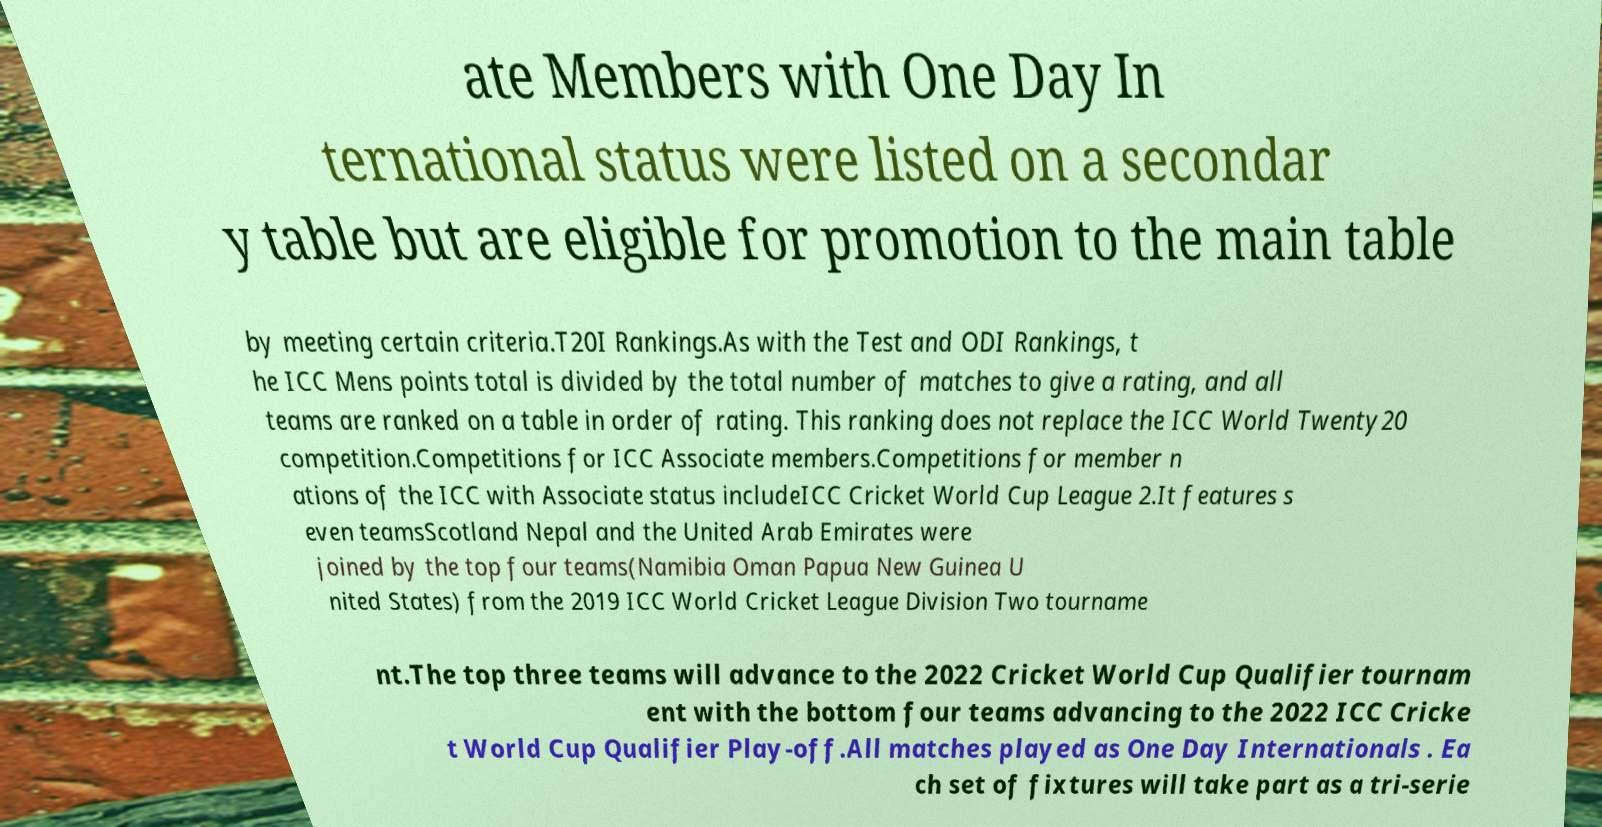For documentation purposes, I need the text within this image transcribed. Could you provide that? ate Members with One Day In ternational status were listed on a secondar y table but are eligible for promotion to the main table by meeting certain criteria.T20I Rankings.As with the Test and ODI Rankings, t he ICC Mens points total is divided by the total number of matches to give a rating, and all teams are ranked on a table in order of rating. This ranking does not replace the ICC World Twenty20 competition.Competitions for ICC Associate members.Competitions for member n ations of the ICC with Associate status includeICC Cricket World Cup League 2.It features s even teamsScotland Nepal and the United Arab Emirates were joined by the top four teams(Namibia Oman Papua New Guinea U nited States) from the 2019 ICC World Cricket League Division Two tourname nt.The top three teams will advance to the 2022 Cricket World Cup Qualifier tournam ent with the bottom four teams advancing to the 2022 ICC Cricke t World Cup Qualifier Play-off.All matches played as One Day Internationals . Ea ch set of fixtures will take part as a tri-serie 